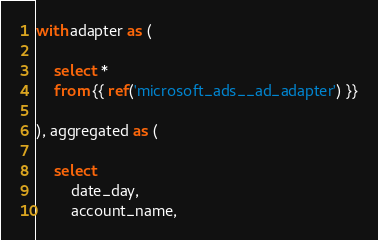<code> <loc_0><loc_0><loc_500><loc_500><_SQL_>with adapter as (

    select *
    from {{ ref('microsoft_ads__ad_adapter') }}

), aggregated as (

    select
        date_day,
        account_name,</code> 